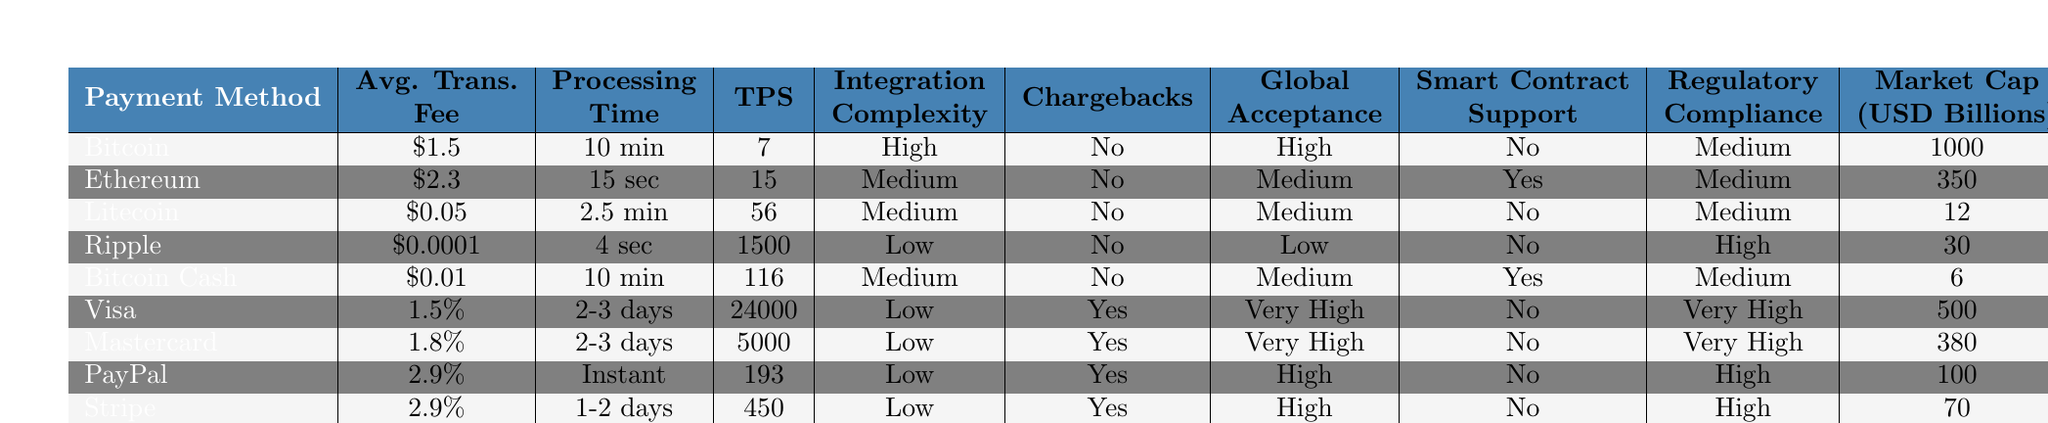What is the average transaction fee for Bitcoin? The table clearly shows that the average transaction fee for Bitcoin is listed under the "Avg. Trans. Fee" column. The value corresponding to Bitcoin is \$1.5.
Answer: \$1.5 How long does it take to process a transaction using Ethereum? Looking at the "Processing Time" for Ethereum in the table, the value is 15 seconds, which indicates how long it takes to process a transaction with this method.
Answer: 15 seconds Which payment method has the highest scalability in transactions per second? By reviewing the "TPS" (Transactions Per Second) column in the table, we find that Visa, with a value of 24000, has the highest scalability.
Answer: Visa Is there smart contract support for Litecoin? The table indicates that Litecoin does not have smart contract support, as shown in the "Smart Contract Support" column where the corresponding value is "No."
Answer: No What is the difference in average transaction fees between Litecoin and Ripple? The average transaction fee for Litecoin is \$0.05 and for Ripple it is \$0.0001. The difference is \$0.05 - \$0.0001 = \$0.0499.
Answer: \$0.0499 Which payment method has the lowest chargeback risk? By examining the "Chargebacks" column, we see that all cryptocurrency options (Bitcoin, Ethereum, Litecoin, Ripple, and Bitcoin Cash) indicate "No," thus all these methods have the lowest chargeback risk.
Answer: Bitcoin, Ethereum, Litecoin, Ripple, Bitcoin Cash Which payment methods have high global acceptance? Looking at the "Global Acceptance" column, the methods with high acceptance are Bitcoin, PayPal, Stripe, and Visa, which are marked "High."
Answer: Bitcoin, PayPal, Stripe, Visa What is the average market cap of all the payment methods listed? We calculate the average market cap using the values from the "Market Cap (USD Billions)" column. The sum of the market caps is 1000 + 350 + 12 + 30 + 6 + 500 + 380 + 100 + 70 + 40 = 2498. Since there are 10 payment methods, the average is 2498/10 = 249.8 billion.
Answer: 249.8 billion Which payment method is the fastest for processing transactions? The "Processing Time" column shows that PayPal, labeled as "Instant," is the fastest method for processing transactions.
Answer: PayPal What are the integration complexities for traditional payment methods like Visa and Mastercard? The table reveals that both Visa and Mastercard have "Low" integration complexity, meaning they should be easier to integrate into the platform.
Answer: Low 